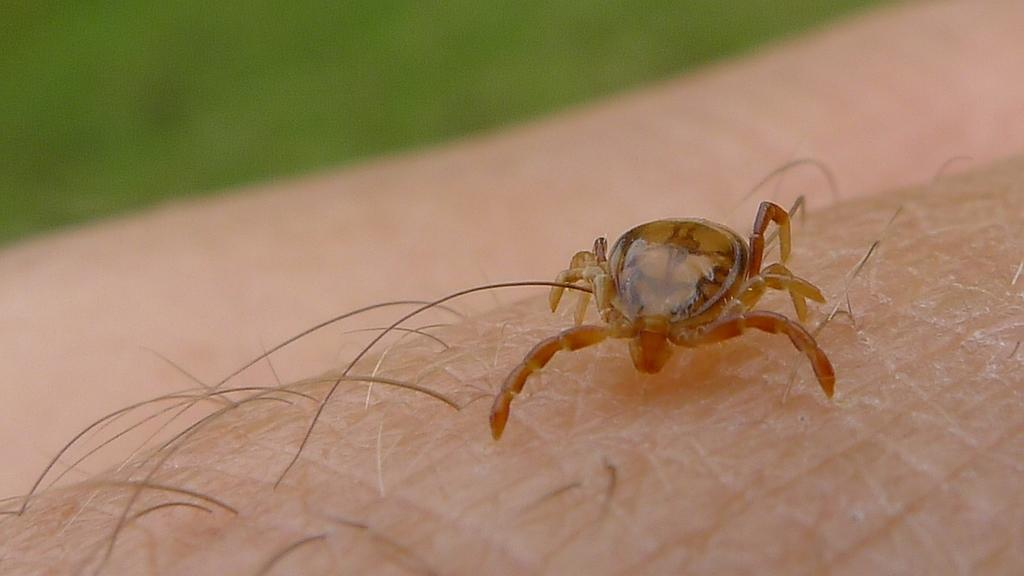What animal is present in the image? There is a crab in the image. Where is the crab located? The crab is on the skin of a person. What type of environment is depicted in the image? There is grass visible in the image, suggesting an outdoor setting. Can you describe the illusion in the image? The illusion in the image is a way, which may be a path or a visual trick. What type of bread can be seen on the person's neck in the image? There is no bread present in the image, and the person's neck is not mentioned in the facts provided. 